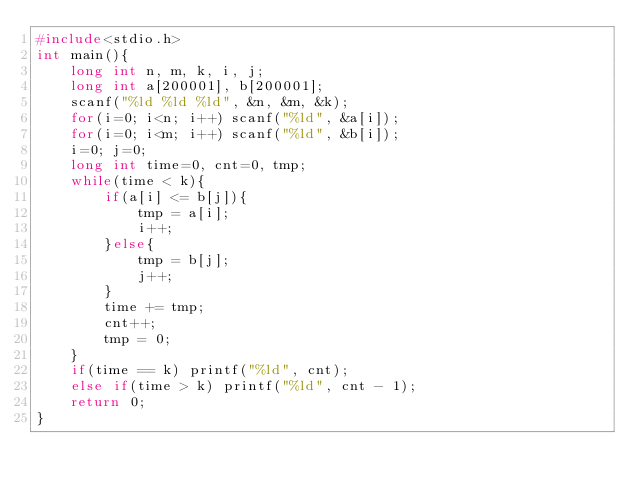Convert code to text. <code><loc_0><loc_0><loc_500><loc_500><_C_>#include<stdio.h>
int main(){
    long int n, m, k, i, j;
    long int a[200001], b[200001];
    scanf("%ld %ld %ld", &n, &m, &k);
    for(i=0; i<n; i++) scanf("%ld", &a[i]);
    for(i=0; i<m; i++) scanf("%ld", &b[i]);
    i=0; j=0;
    long int time=0, cnt=0, tmp;
    while(time < k){
        if(a[i] <= b[j]){
            tmp = a[i];
            i++;
        }else{
            tmp = b[j];
            j++;
        }
        time += tmp;
        cnt++;
        tmp = 0;
    }
    if(time == k) printf("%ld", cnt);
    else if(time > k) printf("%ld", cnt - 1);
    return 0;
}</code> 